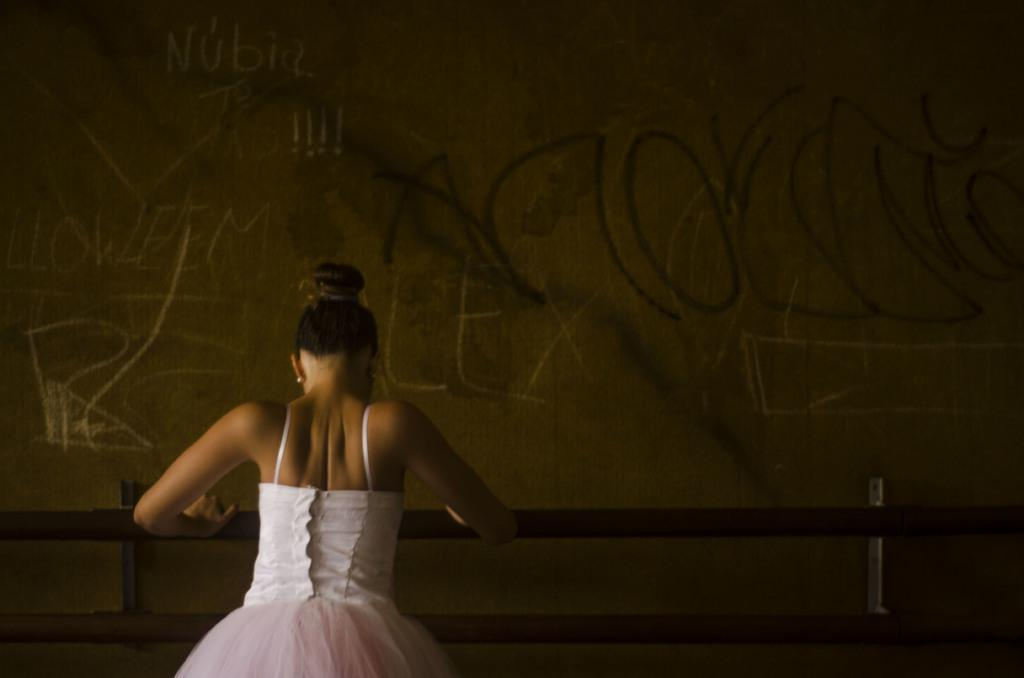Who is present in the image? There is a woman in the image. What is the woman doing in the image? The woman is standing and holding a rod. What can be seen in the background of the image? There are scribblings on the wall in the background of the image. What type of bears can be seen interacting with the crowd in the image? There are no bears or crowd present in the image; it features a woman standing and holding a rod. What scientific discovery is depicted on the wall in the image? There is no scientific discovery depicted on the wall in the image; it has scribblings, but their content is not specified. 